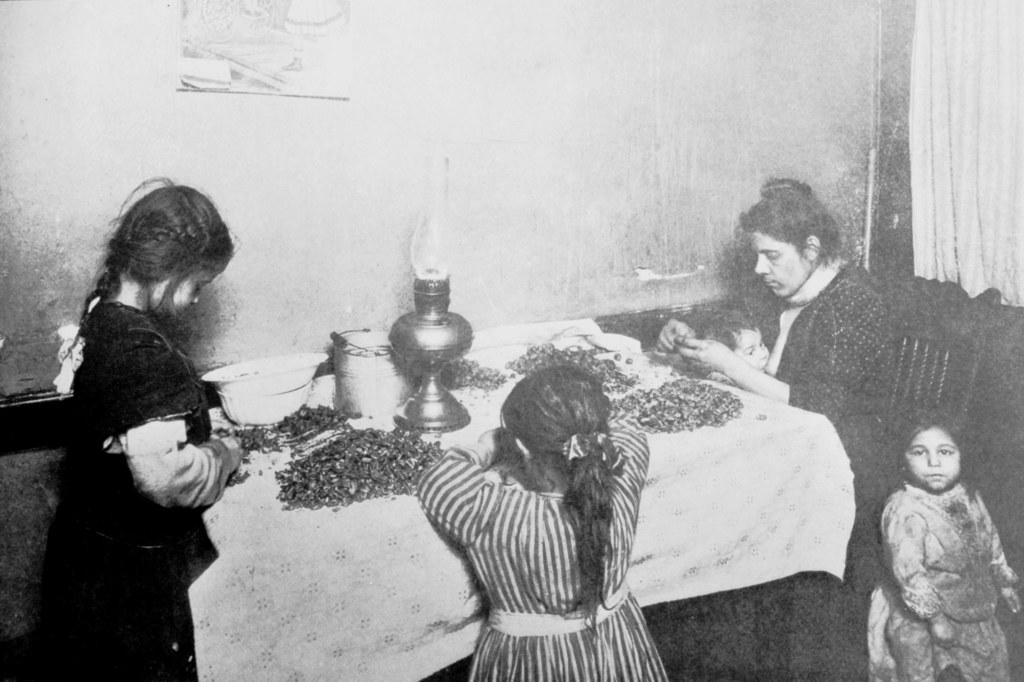What is the color scheme of the image? The image is black and white. What is the woman in the image doing? The woman is sitting on a chair. What is in front of the woman? There is a table in front of the woman. What can be seen on the table? There are items on the table. Who else is present in the image? There are kids around the table. What type of treatment is being administered to the kids in the image? There is no indication of any treatment being administered in the image; it simply shows a woman sitting on a chair, a table, and kids around the table. What territory is being claimed by the kids in the image? There is no mention of any territory being claimed in the image; the kids are simply gathered around a table with a woman. 